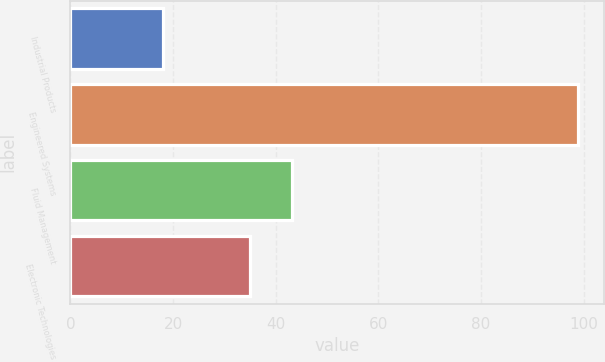Convert chart. <chart><loc_0><loc_0><loc_500><loc_500><bar_chart><fcel>Industrial Products<fcel>Engineered Systems<fcel>Fluid Management<fcel>Electronic Technologies<nl><fcel>18<fcel>99<fcel>43.1<fcel>35<nl></chart> 